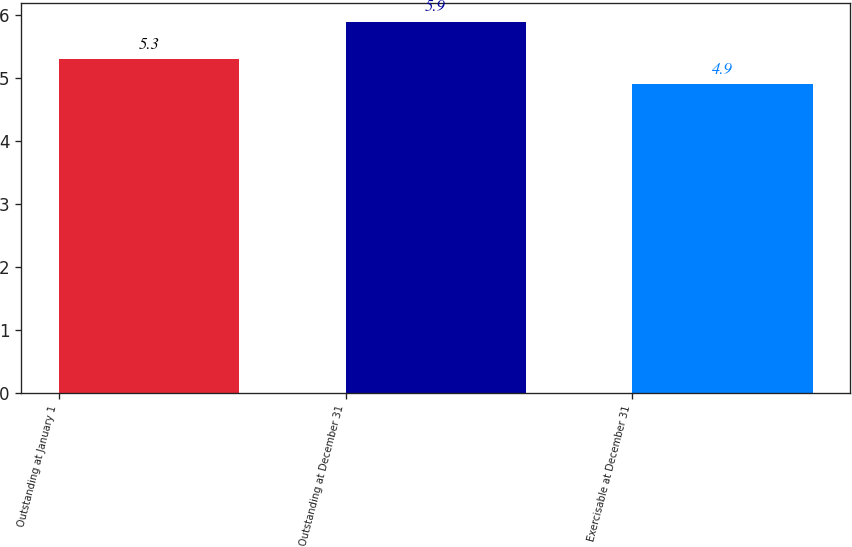<chart> <loc_0><loc_0><loc_500><loc_500><bar_chart><fcel>Outstanding at January 1<fcel>Outstanding at December 31<fcel>Exercisable at December 31<nl><fcel>5.3<fcel>5.9<fcel>4.9<nl></chart> 